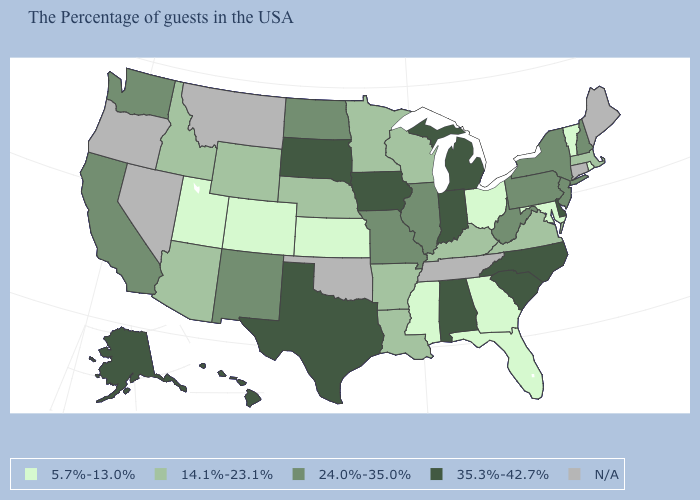What is the value of Pennsylvania?
Short answer required. 24.0%-35.0%. How many symbols are there in the legend?
Write a very short answer. 5. What is the value of West Virginia?
Be succinct. 24.0%-35.0%. What is the value of Mississippi?
Concise answer only. 5.7%-13.0%. Which states have the lowest value in the USA?
Give a very brief answer. Rhode Island, Vermont, Maryland, Ohio, Florida, Georgia, Mississippi, Kansas, Colorado, Utah. Name the states that have a value in the range 35.3%-42.7%?
Keep it brief. Delaware, North Carolina, South Carolina, Michigan, Indiana, Alabama, Iowa, Texas, South Dakota, Alaska, Hawaii. What is the highest value in states that border Mississippi?
Be succinct. 35.3%-42.7%. Among the states that border Tennessee , which have the highest value?
Keep it brief. North Carolina, Alabama. Which states have the lowest value in the MidWest?
Short answer required. Ohio, Kansas. Does Virginia have the highest value in the South?
Concise answer only. No. Does the first symbol in the legend represent the smallest category?
Quick response, please. Yes. Which states have the highest value in the USA?
Concise answer only. Delaware, North Carolina, South Carolina, Michigan, Indiana, Alabama, Iowa, Texas, South Dakota, Alaska, Hawaii. What is the lowest value in the MidWest?
Short answer required. 5.7%-13.0%. What is the value of Minnesota?
Be succinct. 14.1%-23.1%. What is the value of Ohio?
Be succinct. 5.7%-13.0%. 